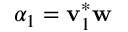<formula> <loc_0><loc_0><loc_500><loc_500>\alpha _ { 1 } = v _ { 1 } ^ { * } w</formula> 